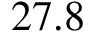<formula> <loc_0><loc_0><loc_500><loc_500>2 7 . 8</formula> 